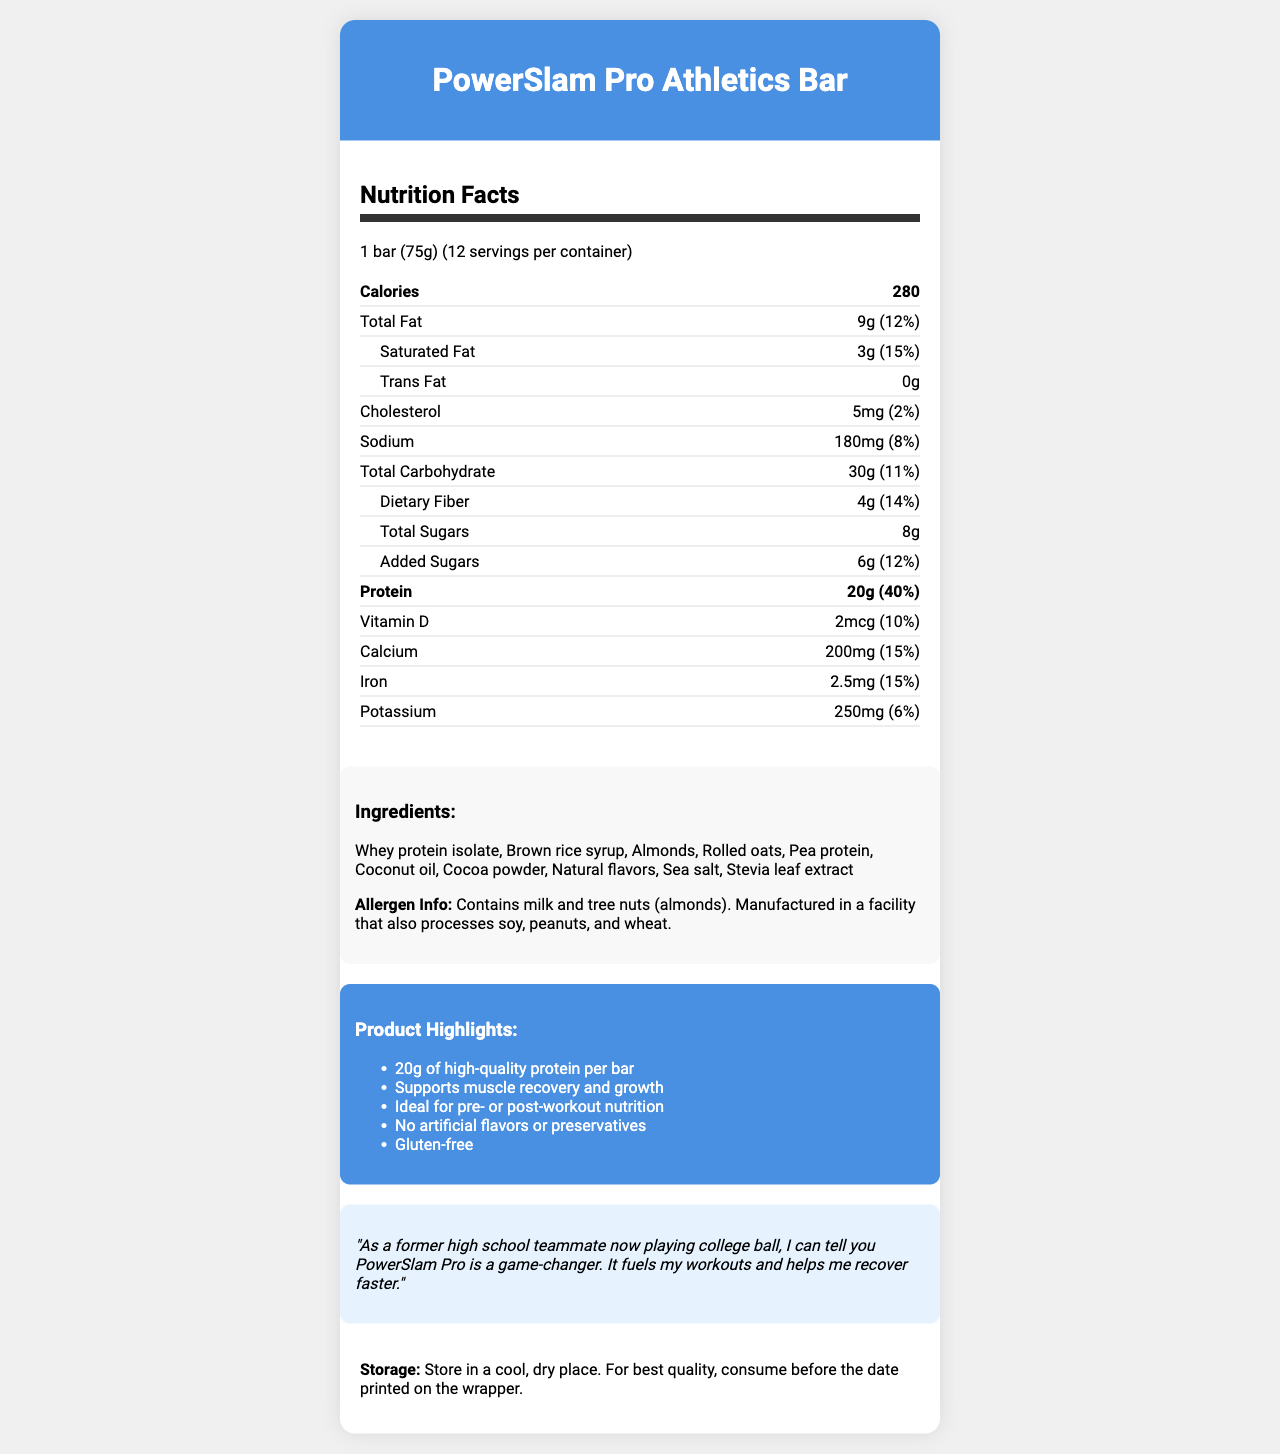what is the serving size of the PowerSlam Pro Athletics Bar? The serving size is clearly specified under the nutrition facts header: "1 bar (75g)".
Answer: 1 bar (75g) how many grams of protein are in each bar? The document lists the protein content as 20g per bar under the nutrition facts.
Answer: 20g how much calcium is present in one serving, and what is its daily value percentage? The document lists calcium as containing 200mg per serving, with a daily value percentage of 15%.
Answer: 200mg (15%) what is the amount of added sugars per serving? Under the dietary information section, the document states that there are 6g of added sugars per serving.
Answer: 6g how many servings are there per container? The document indicates that there are 12 servings per container.
Answer: 12 which two ingredients are allergens mentioned in the document? The allergen information section mentions that the product contains milk and tree nuts (almonds).
Answer: Milk and tree nuts (almonds) what is the percentage of daily value for total fat? The total fat daily value percentage is listed as 12% in the nutrition facts section.
Answer: 12% how much sodium is in one bar? The nutrition facts section specifies the sodium content as 180mg per serving.
Answer: 180mg which claim is NOT made about the PowerSlam Pro Athletics Bar? A. Supports muscle recovery and growth B. Contains artificial flavors C. Gluten-free D. Ideal for pre- or post-workout nutrition The document states "No artificial flavors or preservatives," so it does not claim to contain artificial flavors.
Answer: B. Contains artificial flavors how many calories does one PowerSlam Pro Athletics Bar have? The calories per serving are listed as 280 in the nutrition facts.
Answer: 280 is the PowerSlam Pro Athletics Bar gluten-free? The document explicitly claims that the bar is gluten-free under the marketing claims section.
Answer: Yes describe the entire document. The document is a comprehensive presentation of the PowerSlam Pro Athletics Bar, focusing on its nutrition facts, ingredients, allergen information, marketing claims, athlete testimonial, and storage instructions, aimed at college athletes.
Answer: The document provides detailed information about the nutrition content of the PowerSlam Pro Athletics Bar, highlighting its high protein content and other nutritional elements. It also lists the ingredients, allergen information, and key marketing claims, including testimonials from a university athlete. Storage instructions are also provided. what are the main ingredients of the PowerSlam Pro Athletics Bar? The ingredients list at the bottom of the document enumerates these components.
Answer: Whey protein isolate, Brown rice syrup, Almonds, Rolled oats, Pea protein, Coconut oil, Cocoa powder, Natural flavors, Sea salt, Stevia leaf extract what is the testimonial from the university athlete? The testimonial section of the document specifies this praise from a university athlete.
Answer: "As a former high school teammate now playing college ball, I can tell you PowerSlam Pro is a game-changer. It fuels my workouts and helps me recover faster." is the amount of dietary fiber mentioned? The dietary fiber content is listed as 4g with a daily value percentage of 14%.
Answer: Yes does the document mention if the bar is suitable for vegetarians? The document does not provide any details about whether the bar is suitable for vegetarians.
Answer: Not enough information 